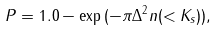<formula> <loc_0><loc_0><loc_500><loc_500>P = 1 . 0 - \exp { ( - \pi \Delta ^ { 2 } n ( < K _ { s } ) ) } ,</formula> 